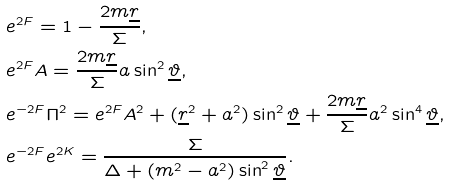<formula> <loc_0><loc_0><loc_500><loc_500>& e ^ { 2 F } = 1 - \frac { 2 m \underline { r } } { \Sigma } , \\ & e ^ { 2 F } A = \frac { 2 m \underline { r } } { \Sigma } a \sin ^ { 2 } \underline { \vartheta } , \\ & e ^ { - 2 F } \Pi ^ { 2 } = e ^ { 2 F } A ^ { 2 } + ( \underline { r } ^ { 2 } + a ^ { 2 } ) \sin ^ { 2 } \underline { \vartheta } + \frac { 2 m \underline { r } } { \Sigma } a ^ { 2 } \sin ^ { 4 } \underline { \vartheta } , \\ & e ^ { - 2 F } e ^ { 2 K } = \frac { \Sigma } { \Delta + ( m ^ { 2 } - a ^ { 2 } ) \sin ^ { 2 } \underline { \vartheta } } .</formula> 